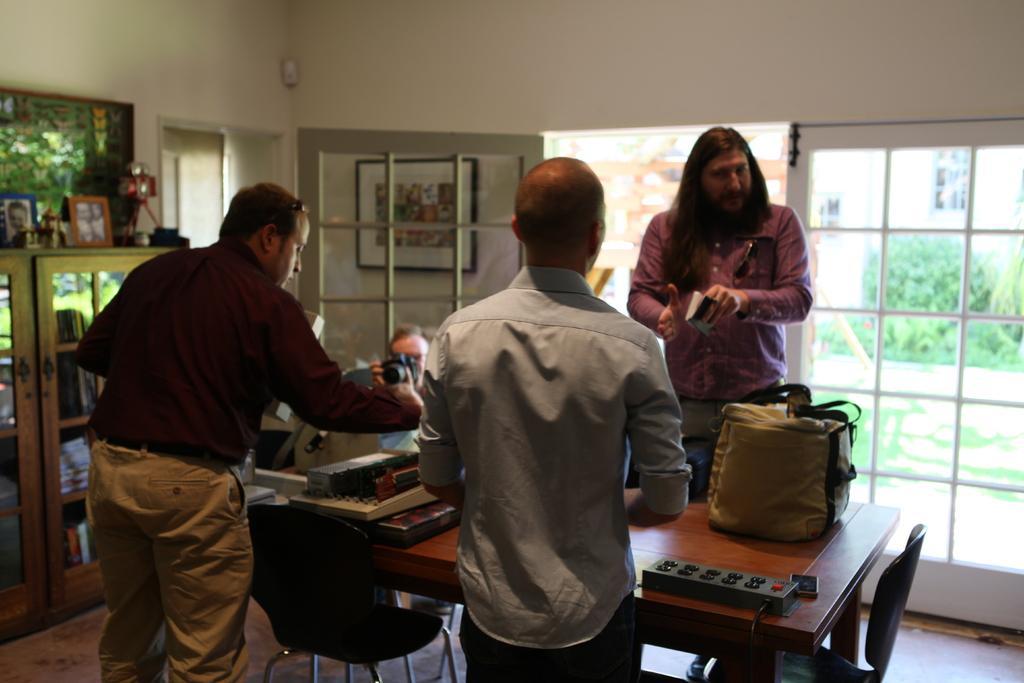In one or two sentences, can you explain what this image depicts? There are three persons standing. In the back a person is standing and holding a book. Another person is sitting in the back and holding a camera. There is a table and a chair. On the table there is a bag, extension board and some other item. In the background there is a door, photo frame, cupboard. Inside the cupboard there are books. On the cupboard there are photo frames. Behind that there is another photo frame. 